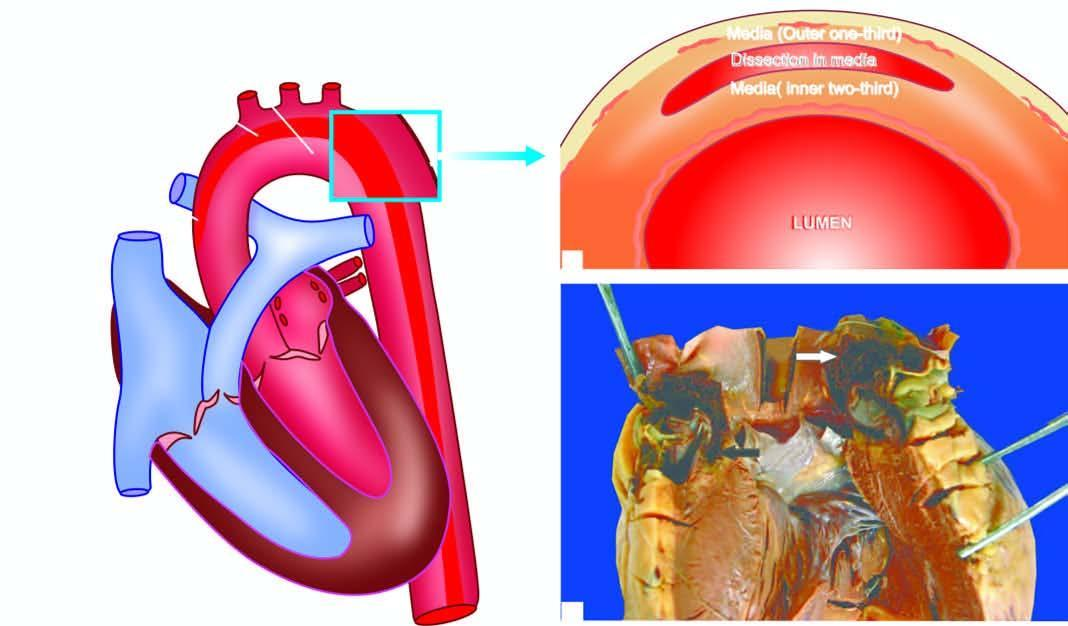what is seen in the arch?
Answer the question using a single word or phrase. An intimal tear 